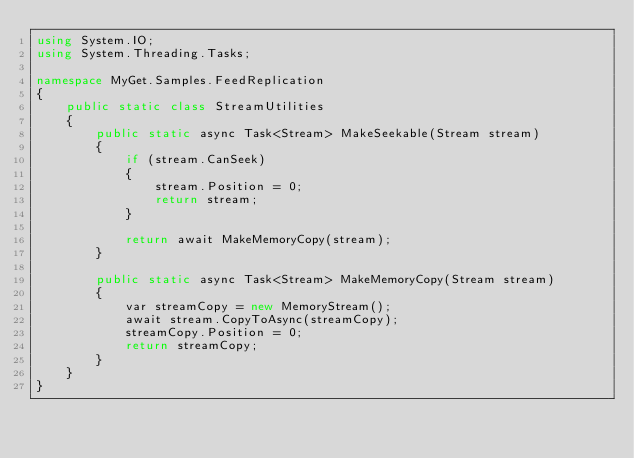Convert code to text. <code><loc_0><loc_0><loc_500><loc_500><_C#_>using System.IO;
using System.Threading.Tasks;

namespace MyGet.Samples.FeedReplication
{
    public static class StreamUtilities
    {
        public static async Task<Stream> MakeSeekable(Stream stream)
        {
            if (stream.CanSeek)
            {
                stream.Position = 0;
                return stream;
            }

            return await MakeMemoryCopy(stream);
        }
        
        public static async Task<Stream> MakeMemoryCopy(Stream stream)
        {
            var streamCopy = new MemoryStream();
            await stream.CopyToAsync(streamCopy);
            streamCopy.Position = 0;
            return streamCopy;
        }
    }
}</code> 